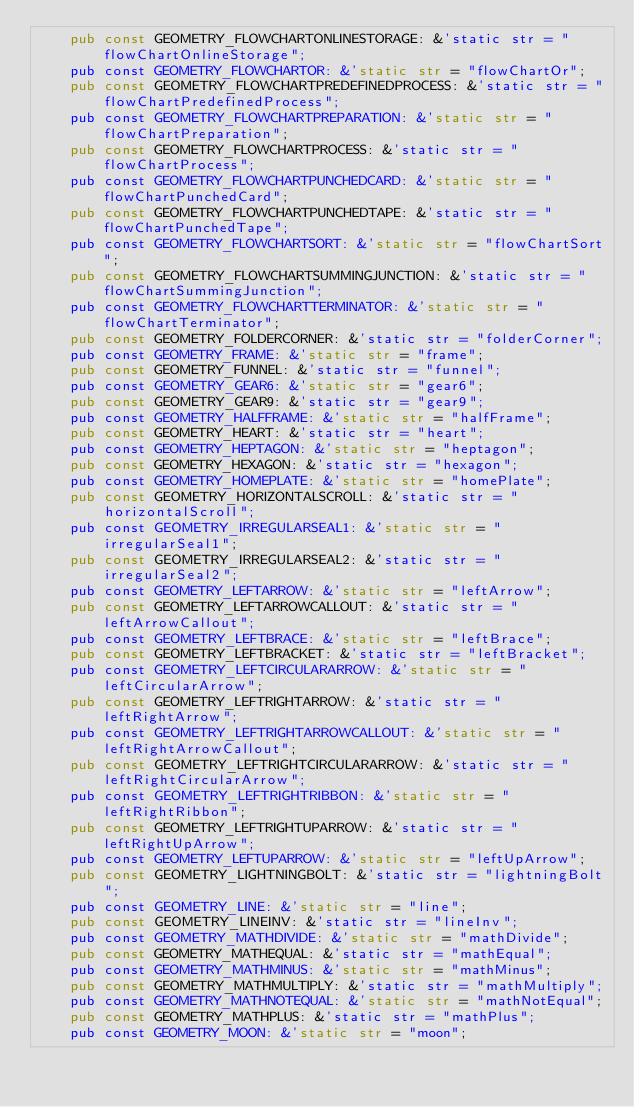<code> <loc_0><loc_0><loc_500><loc_500><_Rust_>    pub const GEOMETRY_FLOWCHARTONLINESTORAGE: &'static str = "flowChartOnlineStorage";
    pub const GEOMETRY_FLOWCHARTOR: &'static str = "flowChartOr";
    pub const GEOMETRY_FLOWCHARTPREDEFINEDPROCESS: &'static str = "flowChartPredefinedProcess";
    pub const GEOMETRY_FLOWCHARTPREPARATION: &'static str = "flowChartPreparation";
    pub const GEOMETRY_FLOWCHARTPROCESS: &'static str = "flowChartProcess";
    pub const GEOMETRY_FLOWCHARTPUNCHEDCARD: &'static str = "flowChartPunchedCard";
    pub const GEOMETRY_FLOWCHARTPUNCHEDTAPE: &'static str = "flowChartPunchedTape";
    pub const GEOMETRY_FLOWCHARTSORT: &'static str = "flowChartSort";
    pub const GEOMETRY_FLOWCHARTSUMMINGJUNCTION: &'static str = "flowChartSummingJunction";
    pub const GEOMETRY_FLOWCHARTTERMINATOR: &'static str = "flowChartTerminator";
    pub const GEOMETRY_FOLDERCORNER: &'static str = "folderCorner";
    pub const GEOMETRY_FRAME: &'static str = "frame";
    pub const GEOMETRY_FUNNEL: &'static str = "funnel";
    pub const GEOMETRY_GEAR6: &'static str = "gear6";
    pub const GEOMETRY_GEAR9: &'static str = "gear9";
    pub const GEOMETRY_HALFFRAME: &'static str = "halfFrame";
    pub const GEOMETRY_HEART: &'static str = "heart";
    pub const GEOMETRY_HEPTAGON: &'static str = "heptagon";
    pub const GEOMETRY_HEXAGON: &'static str = "hexagon";
    pub const GEOMETRY_HOMEPLATE: &'static str = "homePlate";
    pub const GEOMETRY_HORIZONTALSCROLL: &'static str = "horizontalScroll";
    pub const GEOMETRY_IRREGULARSEAL1: &'static str = "irregularSeal1";
    pub const GEOMETRY_IRREGULARSEAL2: &'static str = "irregularSeal2";
    pub const GEOMETRY_LEFTARROW: &'static str = "leftArrow";
    pub const GEOMETRY_LEFTARROWCALLOUT: &'static str = "leftArrowCallout";
    pub const GEOMETRY_LEFTBRACE: &'static str = "leftBrace";
    pub const GEOMETRY_LEFTBRACKET: &'static str = "leftBracket";
    pub const GEOMETRY_LEFTCIRCULARARROW: &'static str = "leftCircularArrow";
    pub const GEOMETRY_LEFTRIGHTARROW: &'static str = "leftRightArrow";
    pub const GEOMETRY_LEFTRIGHTARROWCALLOUT: &'static str = "leftRightArrowCallout";
    pub const GEOMETRY_LEFTRIGHTCIRCULARARROW: &'static str = "leftRightCircularArrow";
    pub const GEOMETRY_LEFTRIGHTRIBBON: &'static str = "leftRightRibbon";
    pub const GEOMETRY_LEFTRIGHTUPARROW: &'static str = "leftRightUpArrow";
    pub const GEOMETRY_LEFTUPARROW: &'static str = "leftUpArrow";
    pub const GEOMETRY_LIGHTNINGBOLT: &'static str = "lightningBolt";
    pub const GEOMETRY_LINE: &'static str = "line";
    pub const GEOMETRY_LINEINV: &'static str = "lineInv";
    pub const GEOMETRY_MATHDIVIDE: &'static str = "mathDivide";
    pub const GEOMETRY_MATHEQUAL: &'static str = "mathEqual";
    pub const GEOMETRY_MATHMINUS: &'static str = "mathMinus";
    pub const GEOMETRY_MATHMULTIPLY: &'static str = "mathMultiply";
    pub const GEOMETRY_MATHNOTEQUAL: &'static str = "mathNotEqual";
    pub const GEOMETRY_MATHPLUS: &'static str = "mathPlus";
    pub const GEOMETRY_MOON: &'static str = "moon";</code> 